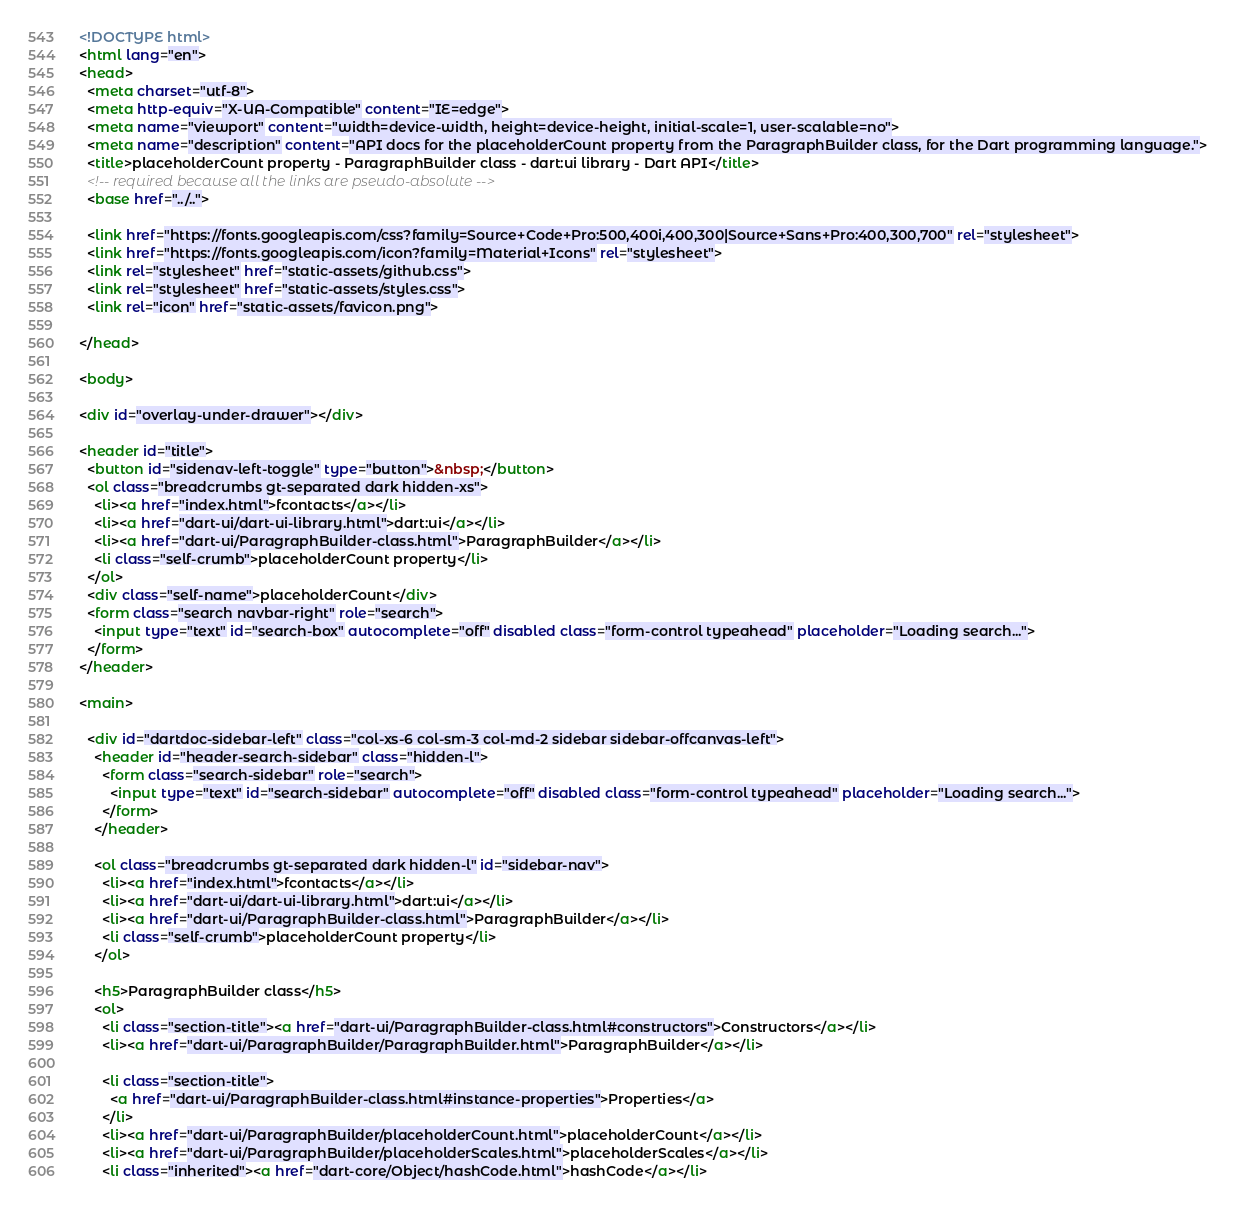<code> <loc_0><loc_0><loc_500><loc_500><_HTML_><!DOCTYPE html>
<html lang="en">
<head>
  <meta charset="utf-8">
  <meta http-equiv="X-UA-Compatible" content="IE=edge">
  <meta name="viewport" content="width=device-width, height=device-height, initial-scale=1, user-scalable=no">
  <meta name="description" content="API docs for the placeholderCount property from the ParagraphBuilder class, for the Dart programming language.">
  <title>placeholderCount property - ParagraphBuilder class - dart:ui library - Dart API</title>
  <!-- required because all the links are pseudo-absolute -->
  <base href="../..">

  <link href="https://fonts.googleapis.com/css?family=Source+Code+Pro:500,400i,400,300|Source+Sans+Pro:400,300,700" rel="stylesheet">
  <link href="https://fonts.googleapis.com/icon?family=Material+Icons" rel="stylesheet">
  <link rel="stylesheet" href="static-assets/github.css">
  <link rel="stylesheet" href="static-assets/styles.css">
  <link rel="icon" href="static-assets/favicon.png">
  
</head>

<body>

<div id="overlay-under-drawer"></div>

<header id="title">
  <button id="sidenav-left-toggle" type="button">&nbsp;</button>
  <ol class="breadcrumbs gt-separated dark hidden-xs">
    <li><a href="index.html">fcontacts</a></li>
    <li><a href="dart-ui/dart-ui-library.html">dart:ui</a></li>
    <li><a href="dart-ui/ParagraphBuilder-class.html">ParagraphBuilder</a></li>
    <li class="self-crumb">placeholderCount property</li>
  </ol>
  <div class="self-name">placeholderCount</div>
  <form class="search navbar-right" role="search">
    <input type="text" id="search-box" autocomplete="off" disabled class="form-control typeahead" placeholder="Loading search...">
  </form>
</header>

<main>

  <div id="dartdoc-sidebar-left" class="col-xs-6 col-sm-3 col-md-2 sidebar sidebar-offcanvas-left">
    <header id="header-search-sidebar" class="hidden-l">
      <form class="search-sidebar" role="search">
        <input type="text" id="search-sidebar" autocomplete="off" disabled class="form-control typeahead" placeholder="Loading search...">
      </form>
    </header>
    
    <ol class="breadcrumbs gt-separated dark hidden-l" id="sidebar-nav">
      <li><a href="index.html">fcontacts</a></li>
      <li><a href="dart-ui/dart-ui-library.html">dart:ui</a></li>
      <li><a href="dart-ui/ParagraphBuilder-class.html">ParagraphBuilder</a></li>
      <li class="self-crumb">placeholderCount property</li>
    </ol>
    
    <h5>ParagraphBuilder class</h5>
    <ol>
      <li class="section-title"><a href="dart-ui/ParagraphBuilder-class.html#constructors">Constructors</a></li>
      <li><a href="dart-ui/ParagraphBuilder/ParagraphBuilder.html">ParagraphBuilder</a></li>
    
      <li class="section-title">
        <a href="dart-ui/ParagraphBuilder-class.html#instance-properties">Properties</a>
      </li>
      <li><a href="dart-ui/ParagraphBuilder/placeholderCount.html">placeholderCount</a></li>
      <li><a href="dart-ui/ParagraphBuilder/placeholderScales.html">placeholderScales</a></li>
      <li class="inherited"><a href="dart-core/Object/hashCode.html">hashCode</a></li></code> 